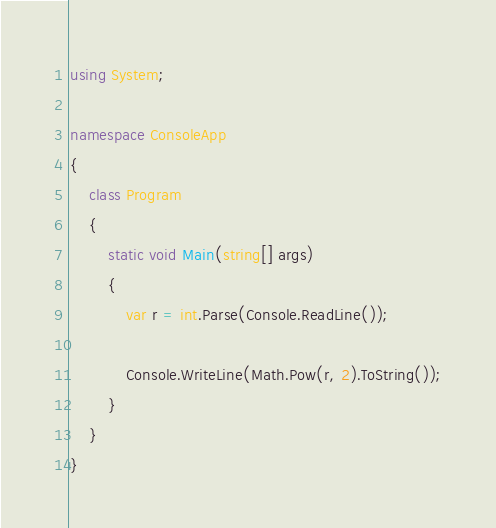<code> <loc_0><loc_0><loc_500><loc_500><_C#_>using System;

namespace ConsoleApp
{
    class Program
    {
        static void Main(string[] args)
        {
            var r = int.Parse(Console.ReadLine());

            Console.WriteLine(Math.Pow(r, 2).ToString());
        }
    }
}
</code> 